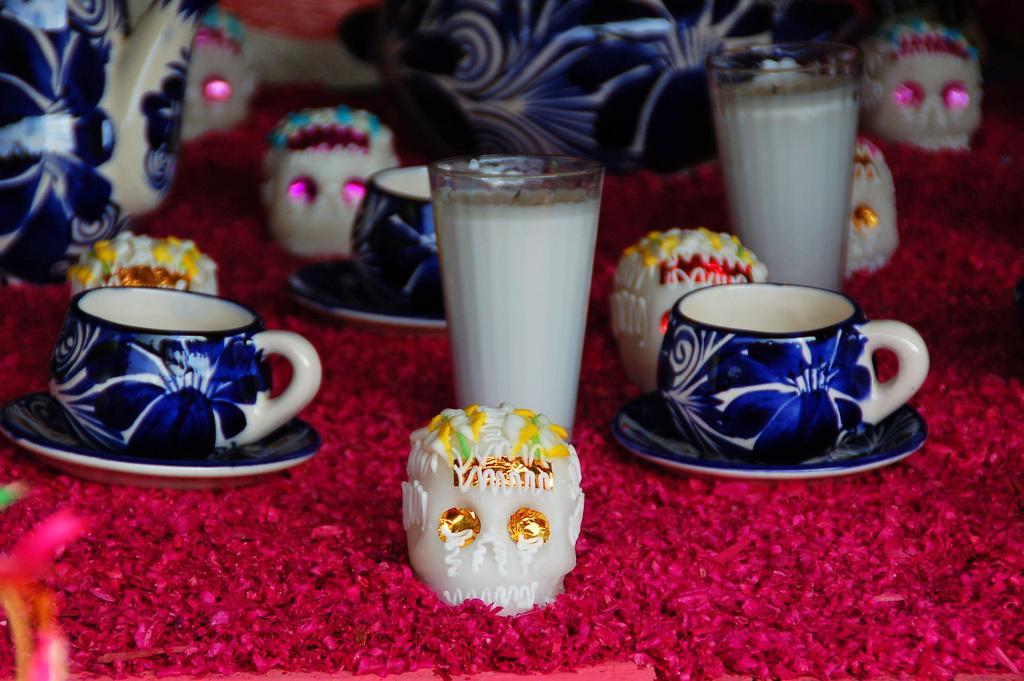Please provide a concise description of this image. There are two blue color cups with saucers. And the glass with white color liquid in it. There are red color flowers. And we can see some white color toy with yellow stones. In background there are some objects. 